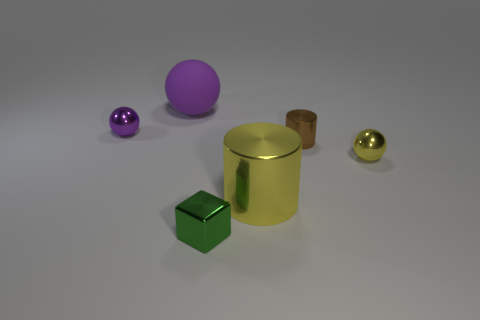Are the tiny brown cylinder and the big sphere made of the same material?
Make the answer very short. No. How many spheres are tiny purple metallic things or purple objects?
Provide a short and direct response. 2. What is the color of the large thing right of the rubber ball that is behind the tiny green object?
Offer a very short reply. Yellow. What is the size of the other shiny object that is the same color as the big shiny object?
Ensure brevity in your answer.  Small. There is a large thing in front of the small metal ball that is left of the yellow sphere; how many purple spheres are right of it?
Make the answer very short. 0. Do the thing that is behind the purple metal thing and the shiny object that is to the left of the green metallic cube have the same shape?
Give a very brief answer. Yes. How many objects are purple spheres or tiny brown rubber things?
Your response must be concise. 2. What material is the purple thing right of the tiny shiny sphere that is on the left side of the large purple sphere?
Provide a succinct answer. Rubber. Is there another thing that has the same color as the large metallic object?
Give a very brief answer. Yes. What color is the other ball that is the same size as the yellow metal sphere?
Your response must be concise. Purple. 